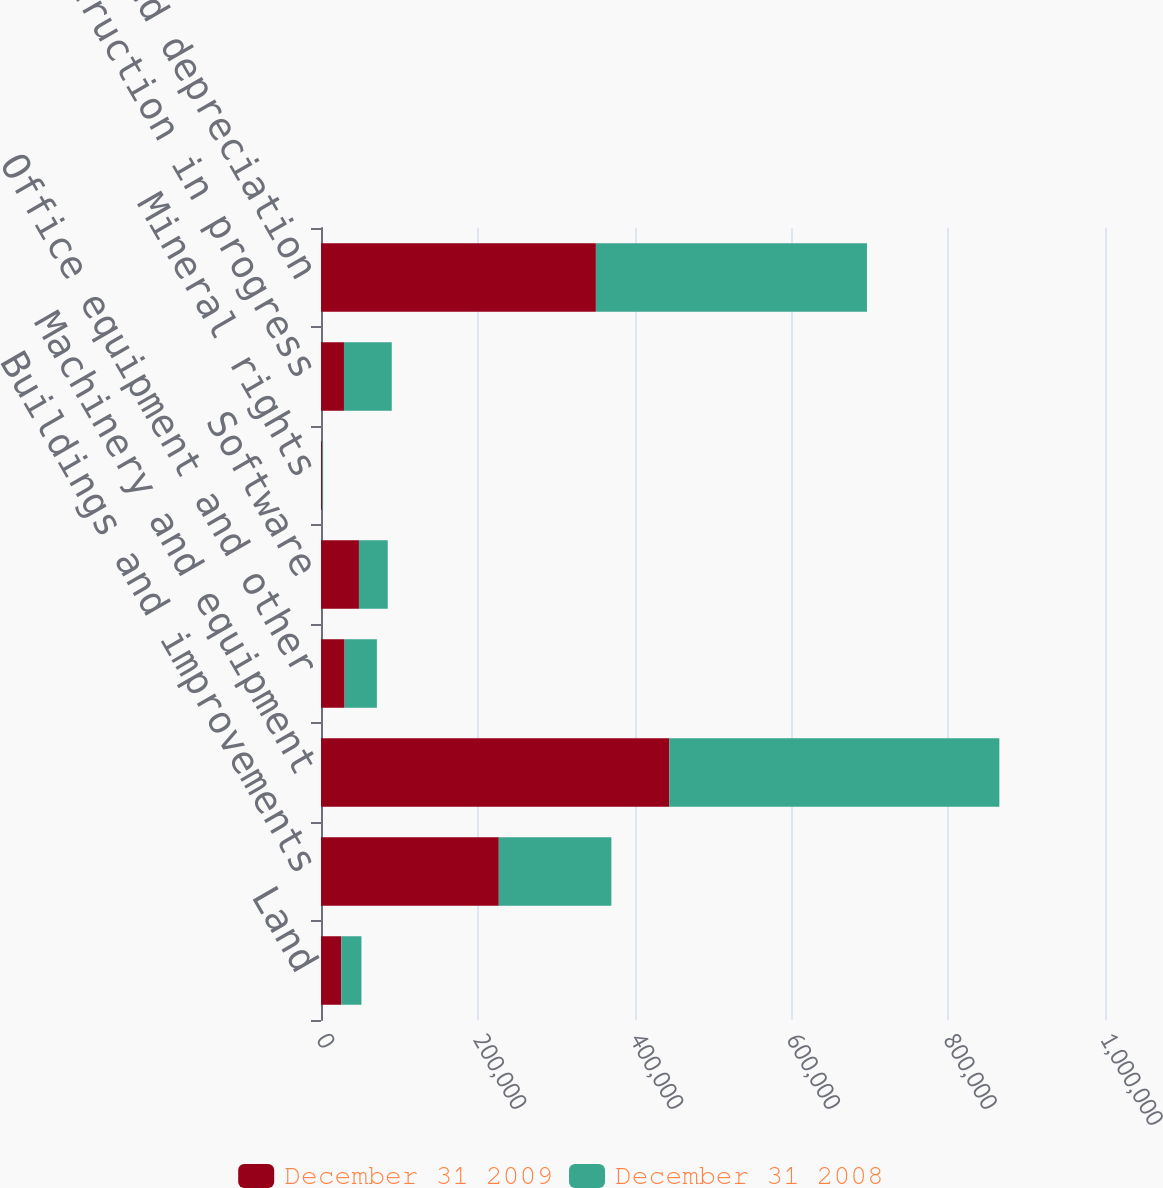Convert chart. <chart><loc_0><loc_0><loc_500><loc_500><stacked_bar_chart><ecel><fcel>Land<fcel>Buildings and improvements<fcel>Machinery and equipment<fcel>Office equipment and other<fcel>Software<fcel>Mineral rights<fcel>Construction in progress<fcel>Less accumulated depreciation<nl><fcel>December 31 2009<fcel>25930<fcel>226783<fcel>444235<fcel>30106<fcel>48395<fcel>1521<fcel>29293<fcel>350627<nl><fcel>December 31 2008<fcel>25659<fcel>143590<fcel>421012<fcel>41169<fcel>36729<fcel>1146<fcel>60949<fcel>345735<nl></chart> 